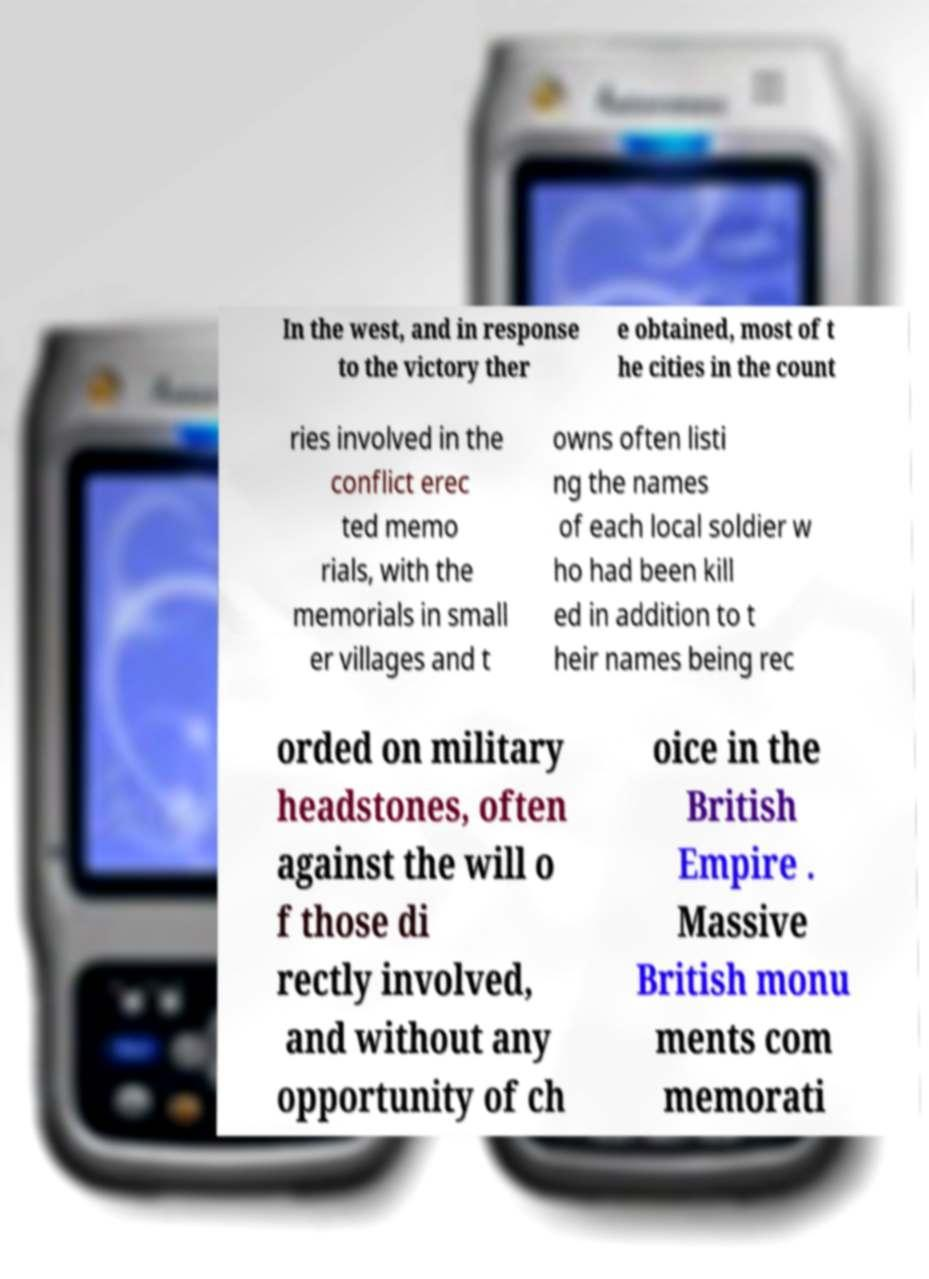I need the written content from this picture converted into text. Can you do that? In the west, and in response to the victory ther e obtained, most of t he cities in the count ries involved in the conflict erec ted memo rials, with the memorials in small er villages and t owns often listi ng the names of each local soldier w ho had been kill ed in addition to t heir names being rec orded on military headstones, often against the will o f those di rectly involved, and without any opportunity of ch oice in the British Empire . Massive British monu ments com memorati 